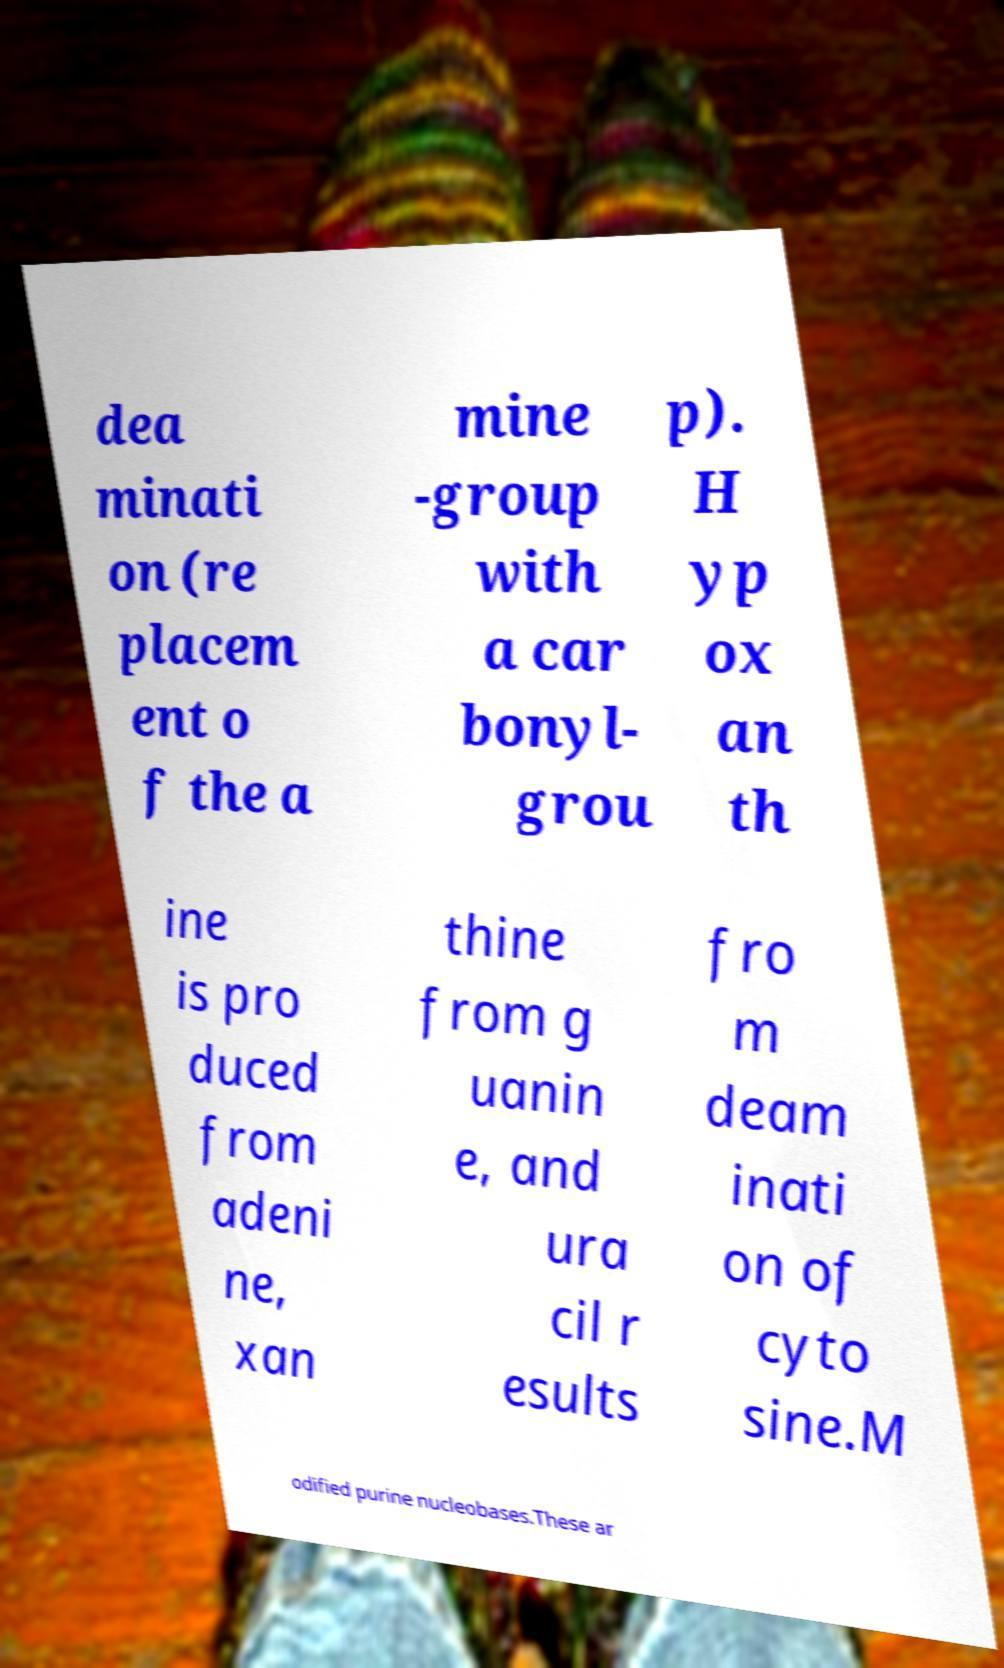Please identify and transcribe the text found in this image. dea minati on (re placem ent o f the a mine -group with a car bonyl- grou p). H yp ox an th ine is pro duced from adeni ne, xan thine from g uanin e, and ura cil r esults fro m deam inati on of cyto sine.M odified purine nucleobases.These ar 